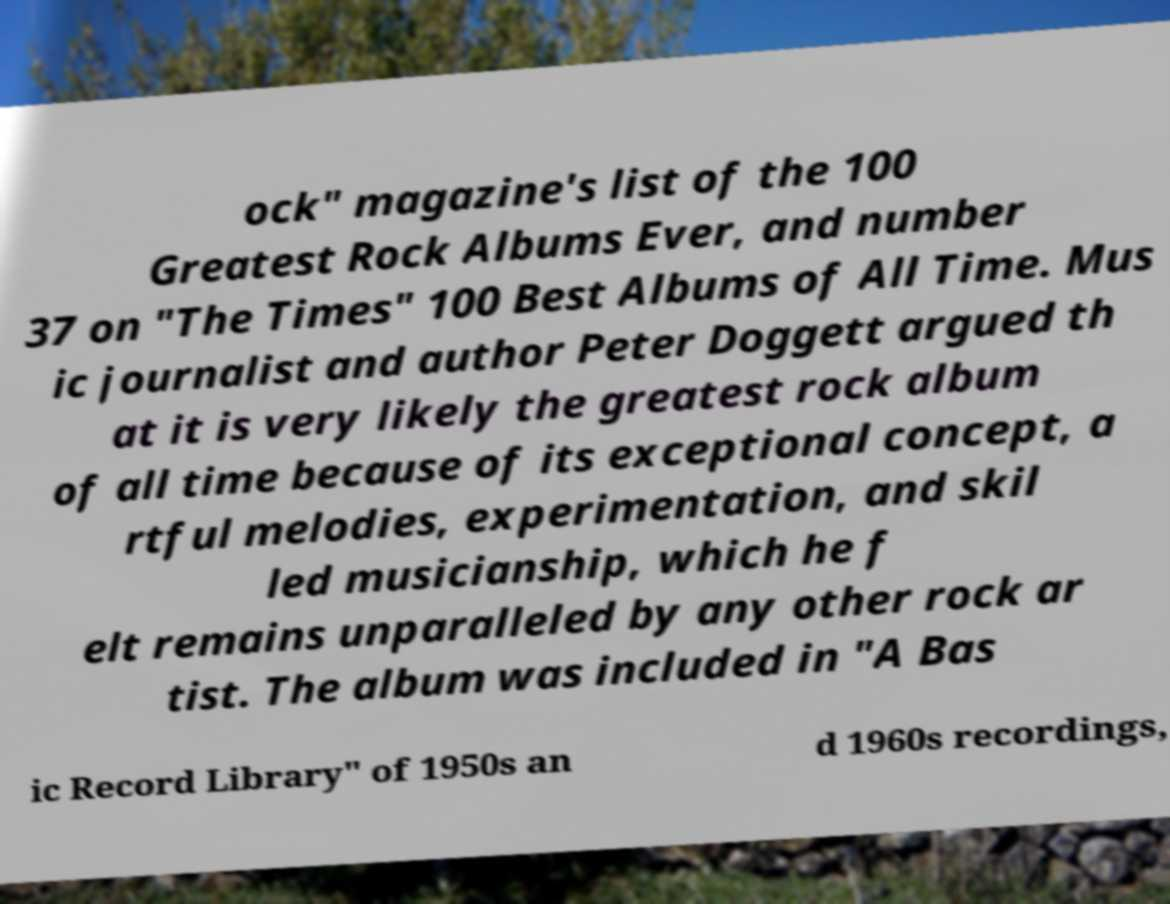For documentation purposes, I need the text within this image transcribed. Could you provide that? ock" magazine's list of the 100 Greatest Rock Albums Ever, and number 37 on "The Times" 100 Best Albums of All Time. Mus ic journalist and author Peter Doggett argued th at it is very likely the greatest rock album of all time because of its exceptional concept, a rtful melodies, experimentation, and skil led musicianship, which he f elt remains unparalleled by any other rock ar tist. The album was included in "A Bas ic Record Library" of 1950s an d 1960s recordings, 